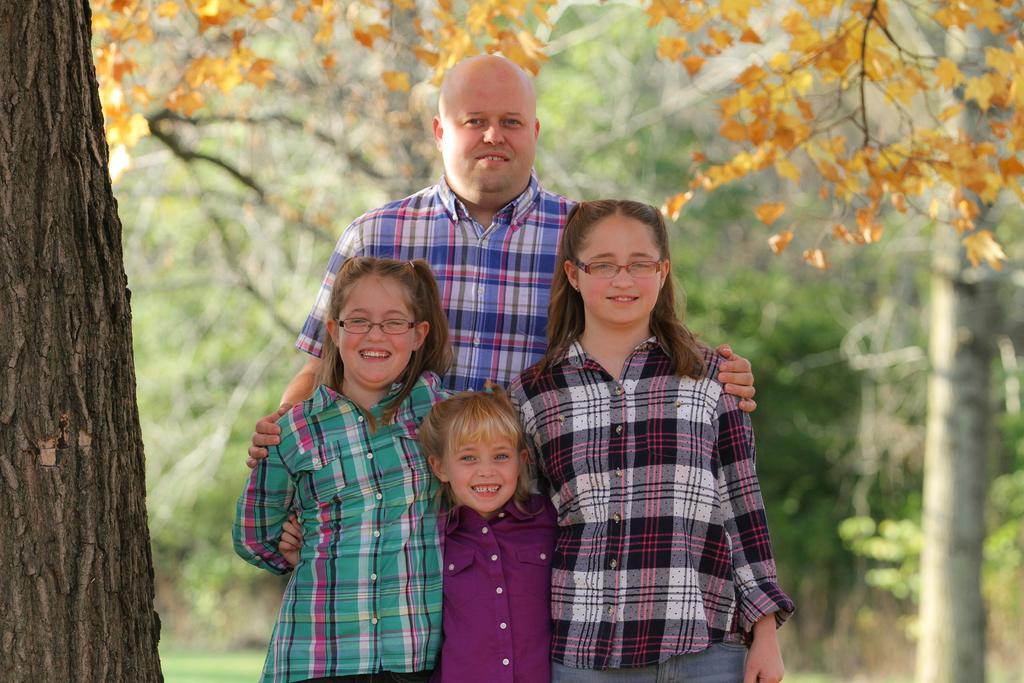Describe this image in one or two sentences. In this image, we can see people and some are wearing glasses. In the background, there are trees. 